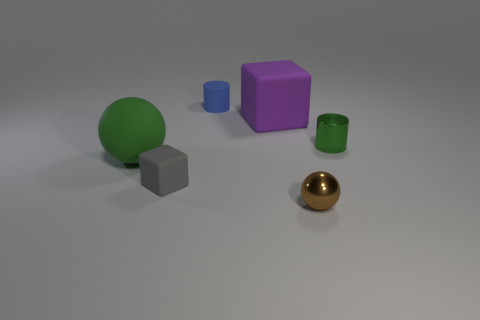Add 1 brown metallic things. How many objects exist? 7 Subtract all cylinders. How many objects are left? 4 Add 2 large green matte objects. How many large green matte objects are left? 3 Add 2 rubber balls. How many rubber balls exist? 3 Subtract 0 brown blocks. How many objects are left? 6 Subtract all big spheres. Subtract all green shiny cylinders. How many objects are left? 4 